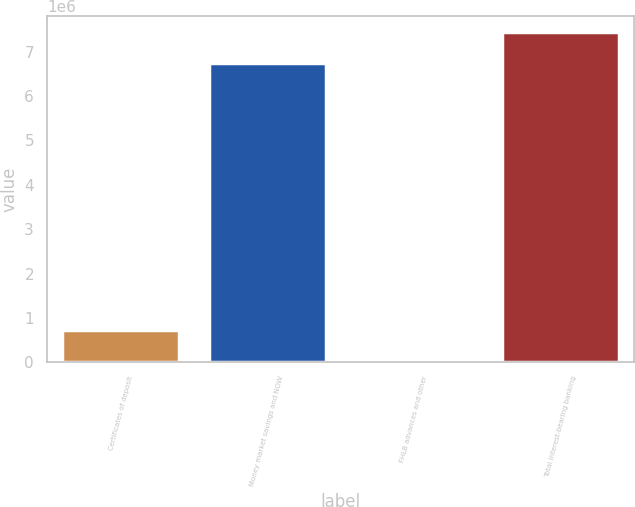<chart> <loc_0><loc_0><loc_500><loc_500><bar_chart><fcel>Certificates of deposit<fcel>Money market savings and NOW<fcel>FHLB advances and other<fcel>Total interest-bearing banking<nl><fcel>728108<fcel>6.74009e+06<fcel>31335<fcel>7.43686e+06<nl></chart> 